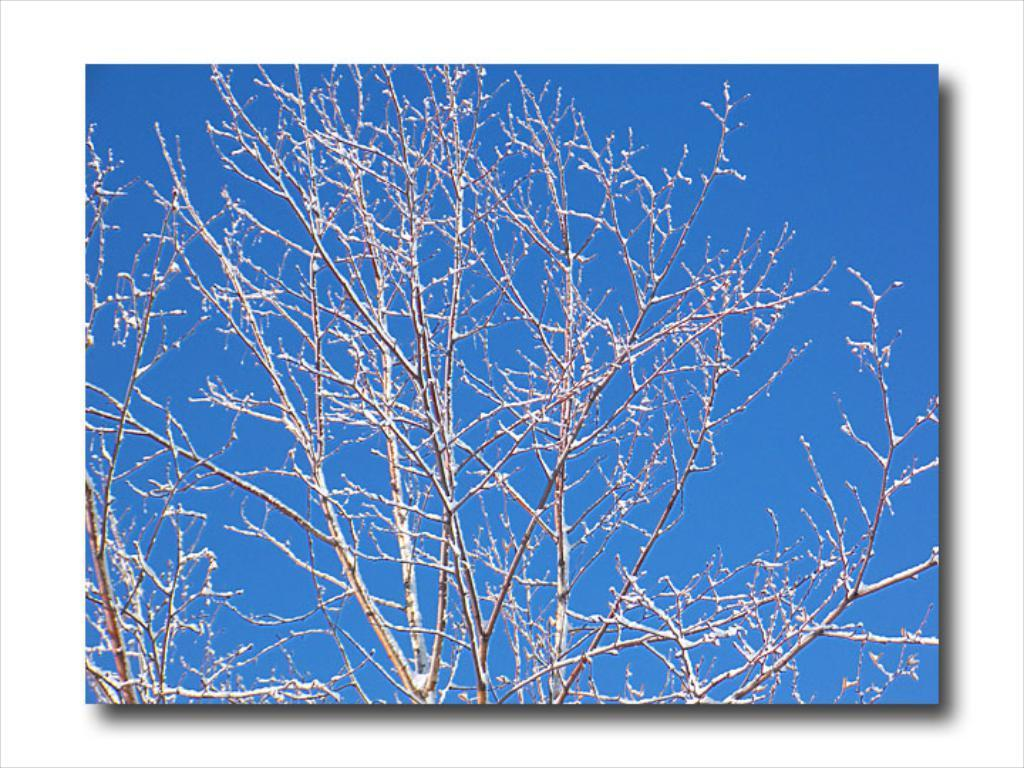What type of natural element can be seen in the image? There is a tree in the image. What part of the natural environment is visible in the image? The sky is visible in the image. What is the color of the background behind the photo? There is a white background behind the photo. How many potatoes are hanging from the tree in the image? There are no potatoes present in the image; it features a tree and the sky. What type of lamp is visible in the image? There is no lamp present in the image. 